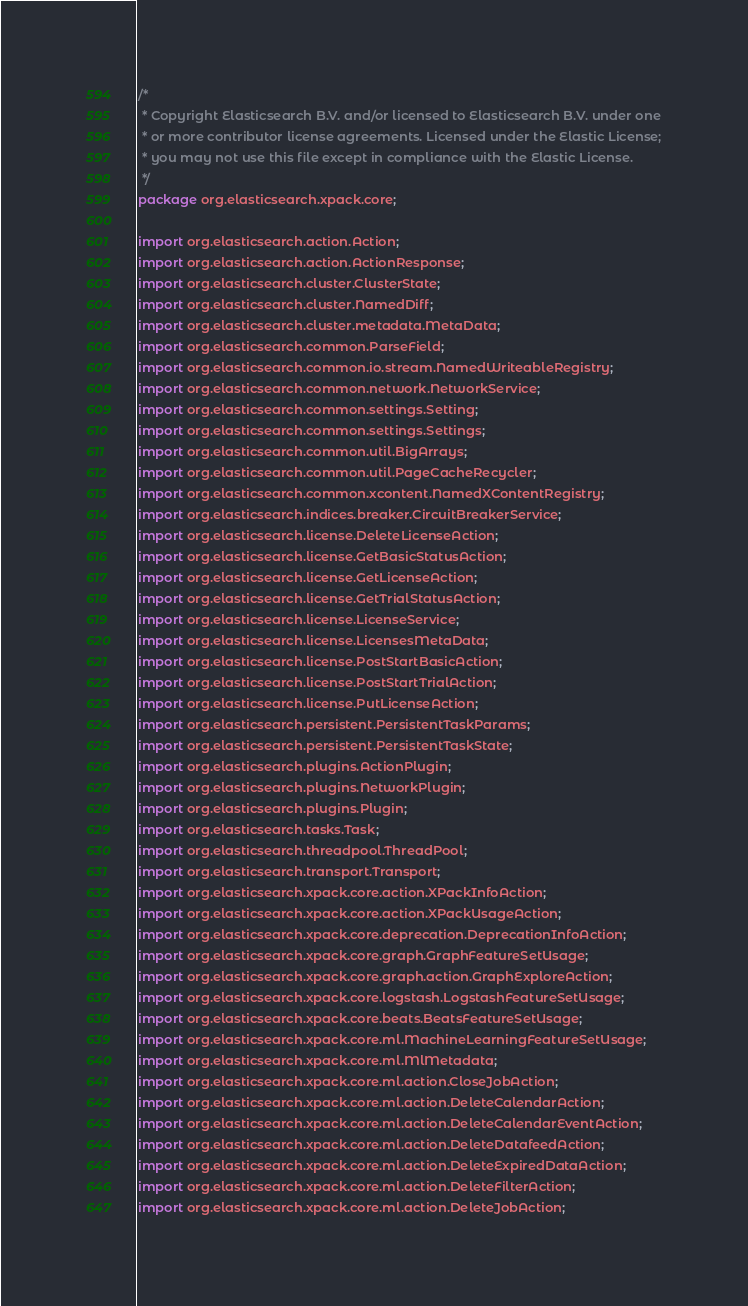Convert code to text. <code><loc_0><loc_0><loc_500><loc_500><_Java_>/*
 * Copyright Elasticsearch B.V. and/or licensed to Elasticsearch B.V. under one
 * or more contributor license agreements. Licensed under the Elastic License;
 * you may not use this file except in compliance with the Elastic License.
 */
package org.elasticsearch.xpack.core;

import org.elasticsearch.action.Action;
import org.elasticsearch.action.ActionResponse;
import org.elasticsearch.cluster.ClusterState;
import org.elasticsearch.cluster.NamedDiff;
import org.elasticsearch.cluster.metadata.MetaData;
import org.elasticsearch.common.ParseField;
import org.elasticsearch.common.io.stream.NamedWriteableRegistry;
import org.elasticsearch.common.network.NetworkService;
import org.elasticsearch.common.settings.Setting;
import org.elasticsearch.common.settings.Settings;
import org.elasticsearch.common.util.BigArrays;
import org.elasticsearch.common.util.PageCacheRecycler;
import org.elasticsearch.common.xcontent.NamedXContentRegistry;
import org.elasticsearch.indices.breaker.CircuitBreakerService;
import org.elasticsearch.license.DeleteLicenseAction;
import org.elasticsearch.license.GetBasicStatusAction;
import org.elasticsearch.license.GetLicenseAction;
import org.elasticsearch.license.GetTrialStatusAction;
import org.elasticsearch.license.LicenseService;
import org.elasticsearch.license.LicensesMetaData;
import org.elasticsearch.license.PostStartBasicAction;
import org.elasticsearch.license.PostStartTrialAction;
import org.elasticsearch.license.PutLicenseAction;
import org.elasticsearch.persistent.PersistentTaskParams;
import org.elasticsearch.persistent.PersistentTaskState;
import org.elasticsearch.plugins.ActionPlugin;
import org.elasticsearch.plugins.NetworkPlugin;
import org.elasticsearch.plugins.Plugin;
import org.elasticsearch.tasks.Task;
import org.elasticsearch.threadpool.ThreadPool;
import org.elasticsearch.transport.Transport;
import org.elasticsearch.xpack.core.action.XPackInfoAction;
import org.elasticsearch.xpack.core.action.XPackUsageAction;
import org.elasticsearch.xpack.core.deprecation.DeprecationInfoAction;
import org.elasticsearch.xpack.core.graph.GraphFeatureSetUsage;
import org.elasticsearch.xpack.core.graph.action.GraphExploreAction;
import org.elasticsearch.xpack.core.logstash.LogstashFeatureSetUsage;
import org.elasticsearch.xpack.core.beats.BeatsFeatureSetUsage;
import org.elasticsearch.xpack.core.ml.MachineLearningFeatureSetUsage;
import org.elasticsearch.xpack.core.ml.MlMetadata;
import org.elasticsearch.xpack.core.ml.action.CloseJobAction;
import org.elasticsearch.xpack.core.ml.action.DeleteCalendarAction;
import org.elasticsearch.xpack.core.ml.action.DeleteCalendarEventAction;
import org.elasticsearch.xpack.core.ml.action.DeleteDatafeedAction;
import org.elasticsearch.xpack.core.ml.action.DeleteExpiredDataAction;
import org.elasticsearch.xpack.core.ml.action.DeleteFilterAction;
import org.elasticsearch.xpack.core.ml.action.DeleteJobAction;</code> 